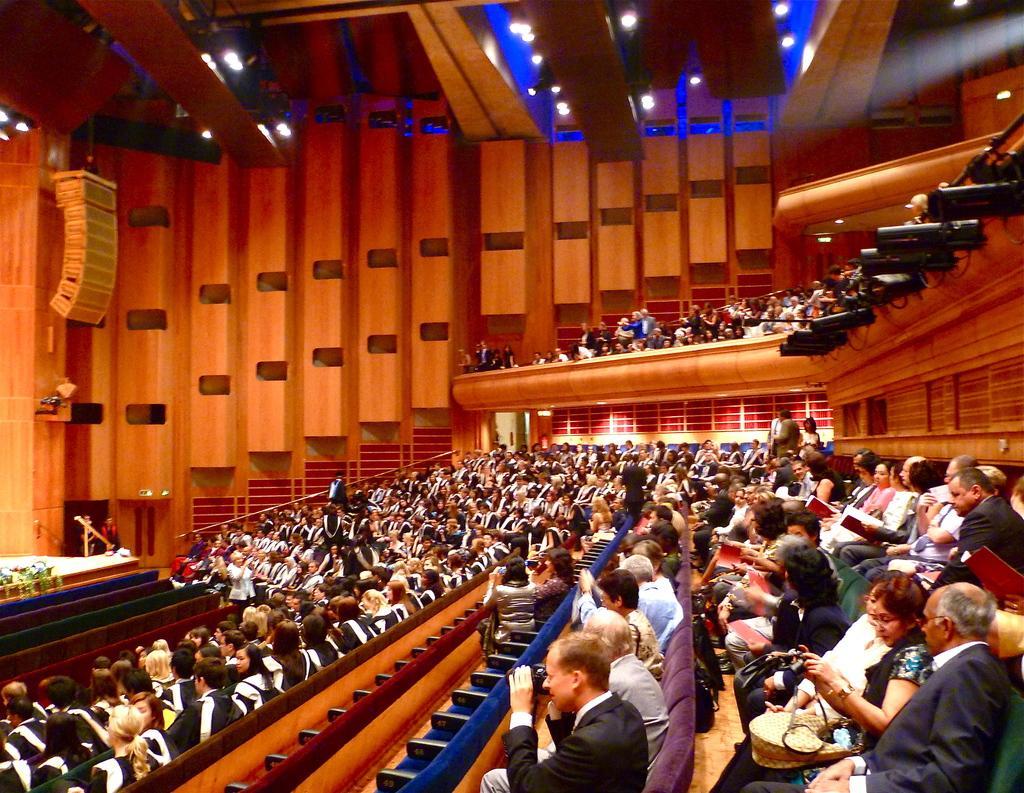Could you give a brief overview of what you see in this image? In this image I can see It looks like an auditorium, in this a group of people are sitting on the sofa chairs, at the top there are ceiling lights. 